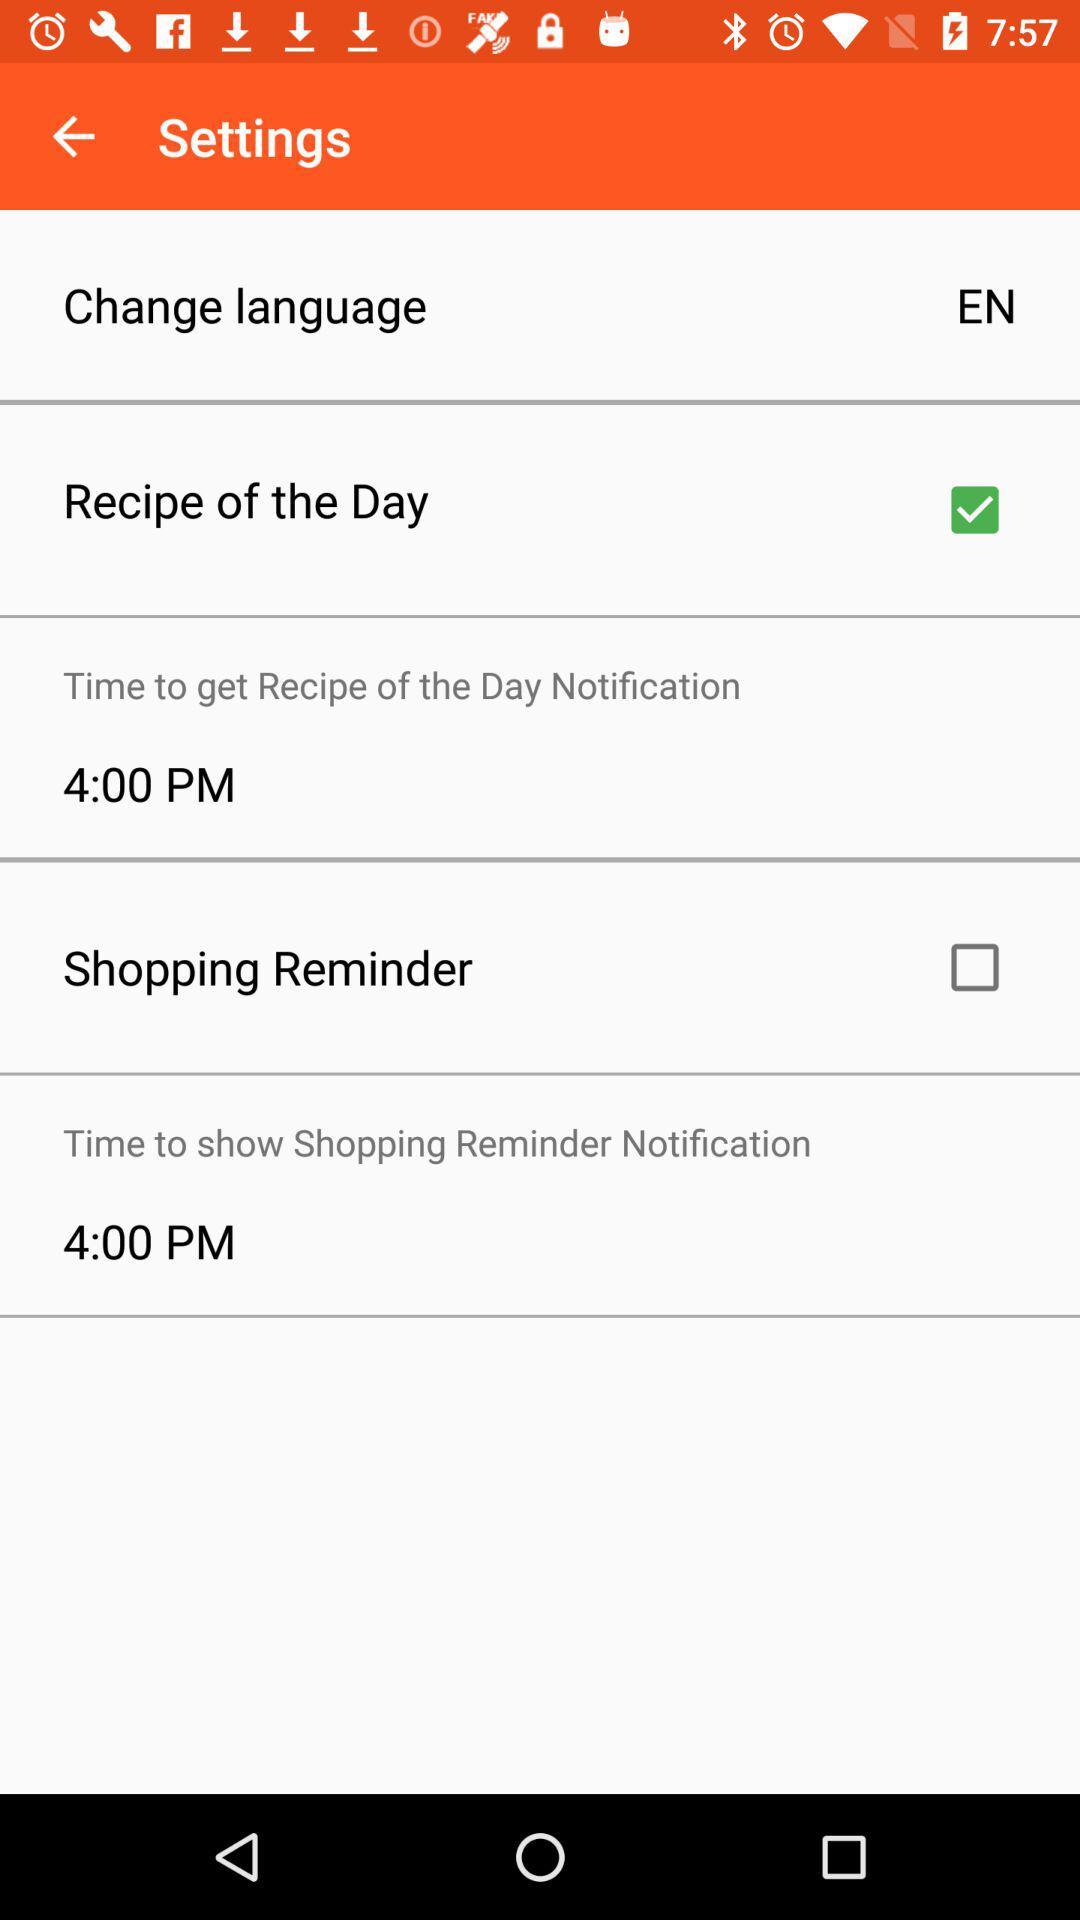What is the status of the shopping reminder? The status is off. 